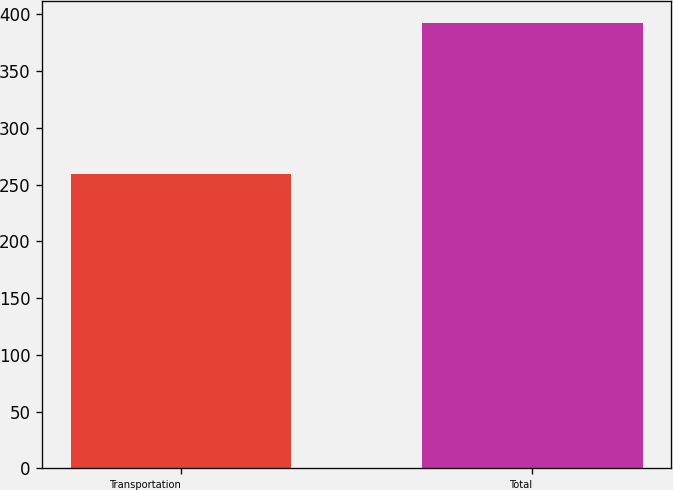<chart> <loc_0><loc_0><loc_500><loc_500><bar_chart><fcel>Transportation<fcel>Total<nl><fcel>259<fcel>392<nl></chart> 